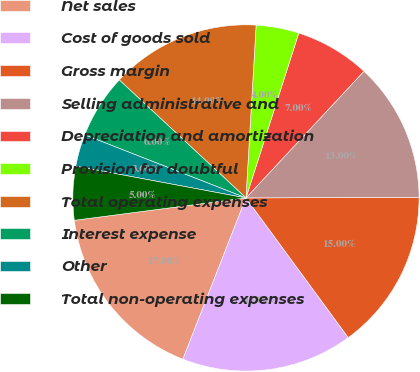Convert chart. <chart><loc_0><loc_0><loc_500><loc_500><pie_chart><fcel>Net sales<fcel>Cost of goods sold<fcel>Gross margin<fcel>Selling administrative and<fcel>Depreciation and amortization<fcel>Provision for doubtful<fcel>Total operating expenses<fcel>Interest expense<fcel>Other<fcel>Total non-operating expenses<nl><fcel>17.0%<fcel>16.0%<fcel>15.0%<fcel>13.0%<fcel>7.0%<fcel>4.0%<fcel>14.0%<fcel>6.0%<fcel>3.0%<fcel>5.0%<nl></chart> 